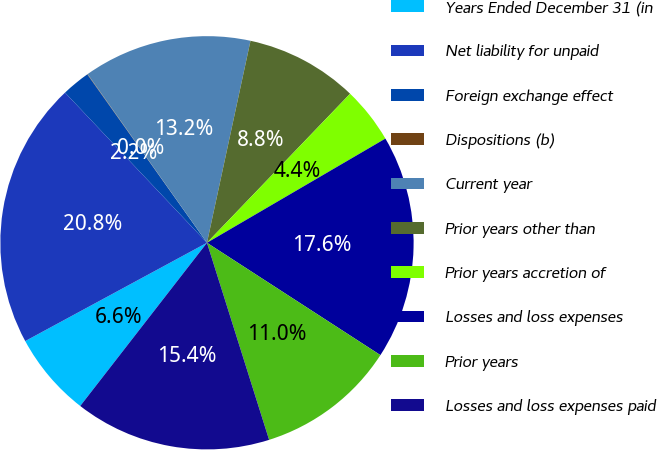Convert chart to OTSL. <chart><loc_0><loc_0><loc_500><loc_500><pie_chart><fcel>Years Ended December 31 (in<fcel>Net liability for unpaid<fcel>Foreign exchange effect<fcel>Dispositions (b)<fcel>Current year<fcel>Prior years other than<fcel>Prior years accretion of<fcel>Losses and loss expenses<fcel>Prior years<fcel>Losses and loss expenses paid<nl><fcel>6.6%<fcel>20.84%<fcel>2.22%<fcel>0.03%<fcel>13.18%<fcel>8.8%<fcel>4.41%<fcel>17.56%<fcel>10.99%<fcel>15.37%<nl></chart> 